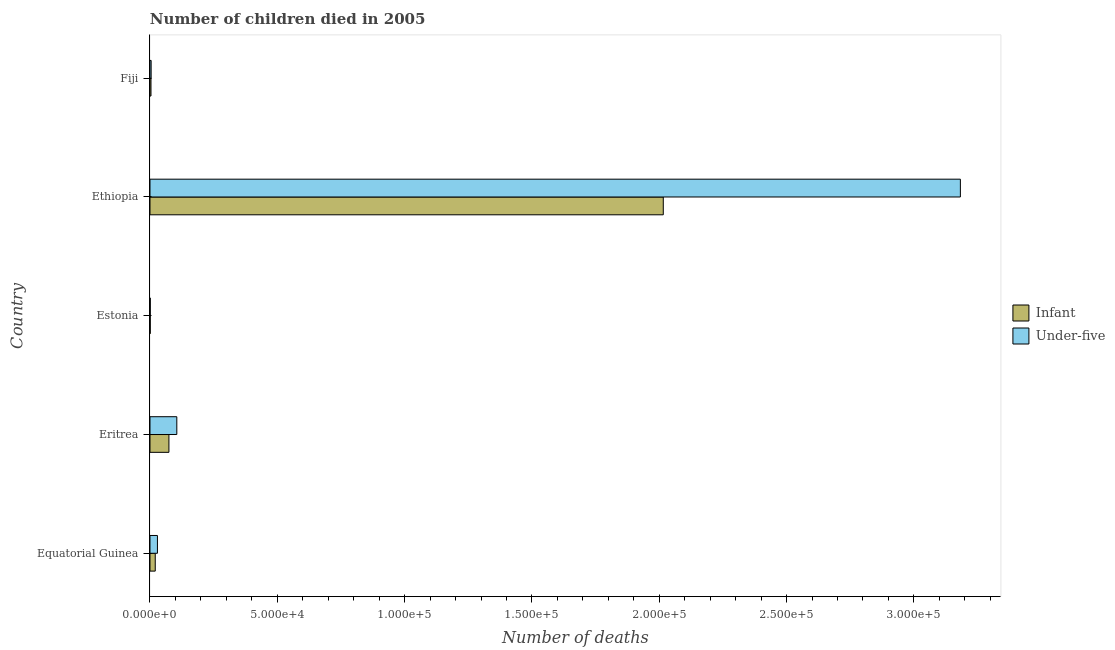How many groups of bars are there?
Give a very brief answer. 5. Are the number of bars per tick equal to the number of legend labels?
Give a very brief answer. Yes. How many bars are there on the 3rd tick from the top?
Make the answer very short. 2. What is the label of the 1st group of bars from the top?
Ensure brevity in your answer.  Fiji. In how many cases, is the number of bars for a given country not equal to the number of legend labels?
Make the answer very short. 0. What is the number of infant deaths in Estonia?
Your answer should be compact. 90. Across all countries, what is the maximum number of infant deaths?
Offer a terse response. 2.02e+05. Across all countries, what is the minimum number of infant deaths?
Ensure brevity in your answer.  90. In which country was the number of infant deaths maximum?
Your answer should be very brief. Ethiopia. In which country was the number of infant deaths minimum?
Your response must be concise. Estonia. What is the total number of under-five deaths in the graph?
Your answer should be compact. 3.32e+05. What is the difference between the number of under-five deaths in Equatorial Guinea and that in Eritrea?
Keep it short and to the point. -7608. What is the difference between the number of infant deaths in Estonia and the number of under-five deaths in Ethiopia?
Give a very brief answer. -3.18e+05. What is the average number of under-five deaths per country?
Provide a short and direct response. 6.65e+04. What is the difference between the number of infant deaths and number of under-five deaths in Fiji?
Offer a very short reply. -65. What is the ratio of the number of infant deaths in Equatorial Guinea to that in Estonia?
Give a very brief answer. 22.94. What is the difference between the highest and the second highest number of infant deaths?
Offer a terse response. 1.94e+05. What is the difference between the highest and the lowest number of under-five deaths?
Keep it short and to the point. 3.18e+05. In how many countries, is the number of under-five deaths greater than the average number of under-five deaths taken over all countries?
Offer a very short reply. 1. What does the 2nd bar from the top in Fiji represents?
Give a very brief answer. Infant. What does the 2nd bar from the bottom in Eritrea represents?
Provide a succinct answer. Under-five. How many bars are there?
Ensure brevity in your answer.  10. How many countries are there in the graph?
Keep it short and to the point. 5. Does the graph contain any zero values?
Make the answer very short. No. How many legend labels are there?
Provide a short and direct response. 2. What is the title of the graph?
Your response must be concise. Number of children died in 2005. Does "Mobile cellular" appear as one of the legend labels in the graph?
Provide a short and direct response. No. What is the label or title of the X-axis?
Keep it short and to the point. Number of deaths. What is the label or title of the Y-axis?
Offer a terse response. Country. What is the Number of deaths in Infant in Equatorial Guinea?
Your response must be concise. 2065. What is the Number of deaths of Under-five in Equatorial Guinea?
Your answer should be compact. 2927. What is the Number of deaths of Infant in Eritrea?
Ensure brevity in your answer.  7434. What is the Number of deaths in Under-five in Eritrea?
Your response must be concise. 1.05e+04. What is the Number of deaths of Infant in Estonia?
Offer a very short reply. 90. What is the Number of deaths in Under-five in Estonia?
Provide a short and direct response. 110. What is the Number of deaths in Infant in Ethiopia?
Your answer should be compact. 2.02e+05. What is the Number of deaths in Under-five in Ethiopia?
Give a very brief answer. 3.18e+05. What is the Number of deaths in Infant in Fiji?
Ensure brevity in your answer.  389. What is the Number of deaths in Under-five in Fiji?
Your answer should be very brief. 454. Across all countries, what is the maximum Number of deaths of Infant?
Give a very brief answer. 2.02e+05. Across all countries, what is the maximum Number of deaths in Under-five?
Ensure brevity in your answer.  3.18e+05. Across all countries, what is the minimum Number of deaths in Under-five?
Your answer should be very brief. 110. What is the total Number of deaths of Infant in the graph?
Offer a very short reply. 2.12e+05. What is the total Number of deaths in Under-five in the graph?
Offer a very short reply. 3.32e+05. What is the difference between the Number of deaths in Infant in Equatorial Guinea and that in Eritrea?
Provide a succinct answer. -5369. What is the difference between the Number of deaths of Under-five in Equatorial Guinea and that in Eritrea?
Your answer should be compact. -7608. What is the difference between the Number of deaths of Infant in Equatorial Guinea and that in Estonia?
Make the answer very short. 1975. What is the difference between the Number of deaths in Under-five in Equatorial Guinea and that in Estonia?
Ensure brevity in your answer.  2817. What is the difference between the Number of deaths of Infant in Equatorial Guinea and that in Ethiopia?
Provide a succinct answer. -2.00e+05. What is the difference between the Number of deaths of Under-five in Equatorial Guinea and that in Ethiopia?
Your answer should be compact. -3.15e+05. What is the difference between the Number of deaths of Infant in Equatorial Guinea and that in Fiji?
Your answer should be very brief. 1676. What is the difference between the Number of deaths in Under-five in Equatorial Guinea and that in Fiji?
Your answer should be very brief. 2473. What is the difference between the Number of deaths in Infant in Eritrea and that in Estonia?
Make the answer very short. 7344. What is the difference between the Number of deaths in Under-five in Eritrea and that in Estonia?
Offer a very short reply. 1.04e+04. What is the difference between the Number of deaths of Infant in Eritrea and that in Ethiopia?
Your answer should be compact. -1.94e+05. What is the difference between the Number of deaths in Under-five in Eritrea and that in Ethiopia?
Offer a very short reply. -3.08e+05. What is the difference between the Number of deaths of Infant in Eritrea and that in Fiji?
Your answer should be compact. 7045. What is the difference between the Number of deaths in Under-five in Eritrea and that in Fiji?
Offer a very short reply. 1.01e+04. What is the difference between the Number of deaths of Infant in Estonia and that in Ethiopia?
Provide a succinct answer. -2.01e+05. What is the difference between the Number of deaths in Under-five in Estonia and that in Ethiopia?
Give a very brief answer. -3.18e+05. What is the difference between the Number of deaths of Infant in Estonia and that in Fiji?
Your response must be concise. -299. What is the difference between the Number of deaths in Under-five in Estonia and that in Fiji?
Give a very brief answer. -344. What is the difference between the Number of deaths of Infant in Ethiopia and that in Fiji?
Your answer should be very brief. 2.01e+05. What is the difference between the Number of deaths of Under-five in Ethiopia and that in Fiji?
Provide a short and direct response. 3.18e+05. What is the difference between the Number of deaths in Infant in Equatorial Guinea and the Number of deaths in Under-five in Eritrea?
Ensure brevity in your answer.  -8470. What is the difference between the Number of deaths of Infant in Equatorial Guinea and the Number of deaths of Under-five in Estonia?
Give a very brief answer. 1955. What is the difference between the Number of deaths of Infant in Equatorial Guinea and the Number of deaths of Under-five in Ethiopia?
Provide a succinct answer. -3.16e+05. What is the difference between the Number of deaths in Infant in Equatorial Guinea and the Number of deaths in Under-five in Fiji?
Provide a short and direct response. 1611. What is the difference between the Number of deaths in Infant in Eritrea and the Number of deaths in Under-five in Estonia?
Your response must be concise. 7324. What is the difference between the Number of deaths in Infant in Eritrea and the Number of deaths in Under-five in Ethiopia?
Your answer should be compact. -3.11e+05. What is the difference between the Number of deaths of Infant in Eritrea and the Number of deaths of Under-five in Fiji?
Your answer should be very brief. 6980. What is the difference between the Number of deaths in Infant in Estonia and the Number of deaths in Under-five in Ethiopia?
Ensure brevity in your answer.  -3.18e+05. What is the difference between the Number of deaths of Infant in Estonia and the Number of deaths of Under-five in Fiji?
Your answer should be compact. -364. What is the difference between the Number of deaths of Infant in Ethiopia and the Number of deaths of Under-five in Fiji?
Your response must be concise. 2.01e+05. What is the average Number of deaths of Infant per country?
Your response must be concise. 4.23e+04. What is the average Number of deaths of Under-five per country?
Provide a succinct answer. 6.65e+04. What is the difference between the Number of deaths of Infant and Number of deaths of Under-five in Equatorial Guinea?
Make the answer very short. -862. What is the difference between the Number of deaths of Infant and Number of deaths of Under-five in Eritrea?
Provide a succinct answer. -3101. What is the difference between the Number of deaths in Infant and Number of deaths in Under-five in Ethiopia?
Your response must be concise. -1.17e+05. What is the difference between the Number of deaths of Infant and Number of deaths of Under-five in Fiji?
Keep it short and to the point. -65. What is the ratio of the Number of deaths of Infant in Equatorial Guinea to that in Eritrea?
Provide a succinct answer. 0.28. What is the ratio of the Number of deaths in Under-five in Equatorial Guinea to that in Eritrea?
Ensure brevity in your answer.  0.28. What is the ratio of the Number of deaths in Infant in Equatorial Guinea to that in Estonia?
Provide a succinct answer. 22.94. What is the ratio of the Number of deaths of Under-five in Equatorial Guinea to that in Estonia?
Keep it short and to the point. 26.61. What is the ratio of the Number of deaths in Infant in Equatorial Guinea to that in Ethiopia?
Offer a very short reply. 0.01. What is the ratio of the Number of deaths of Under-five in Equatorial Guinea to that in Ethiopia?
Your answer should be compact. 0.01. What is the ratio of the Number of deaths of Infant in Equatorial Guinea to that in Fiji?
Offer a very short reply. 5.31. What is the ratio of the Number of deaths in Under-five in Equatorial Guinea to that in Fiji?
Your answer should be compact. 6.45. What is the ratio of the Number of deaths in Infant in Eritrea to that in Estonia?
Your answer should be compact. 82.6. What is the ratio of the Number of deaths of Under-five in Eritrea to that in Estonia?
Offer a terse response. 95.77. What is the ratio of the Number of deaths in Infant in Eritrea to that in Ethiopia?
Your answer should be very brief. 0.04. What is the ratio of the Number of deaths in Under-five in Eritrea to that in Ethiopia?
Your answer should be very brief. 0.03. What is the ratio of the Number of deaths of Infant in Eritrea to that in Fiji?
Ensure brevity in your answer.  19.11. What is the ratio of the Number of deaths of Under-five in Eritrea to that in Fiji?
Make the answer very short. 23.2. What is the ratio of the Number of deaths in Under-five in Estonia to that in Ethiopia?
Make the answer very short. 0. What is the ratio of the Number of deaths of Infant in Estonia to that in Fiji?
Ensure brevity in your answer.  0.23. What is the ratio of the Number of deaths of Under-five in Estonia to that in Fiji?
Make the answer very short. 0.24. What is the ratio of the Number of deaths of Infant in Ethiopia to that in Fiji?
Your answer should be compact. 518.2. What is the ratio of the Number of deaths of Under-five in Ethiopia to that in Fiji?
Give a very brief answer. 701.01. What is the difference between the highest and the second highest Number of deaths in Infant?
Make the answer very short. 1.94e+05. What is the difference between the highest and the second highest Number of deaths of Under-five?
Keep it short and to the point. 3.08e+05. What is the difference between the highest and the lowest Number of deaths of Infant?
Make the answer very short. 2.01e+05. What is the difference between the highest and the lowest Number of deaths in Under-five?
Provide a succinct answer. 3.18e+05. 